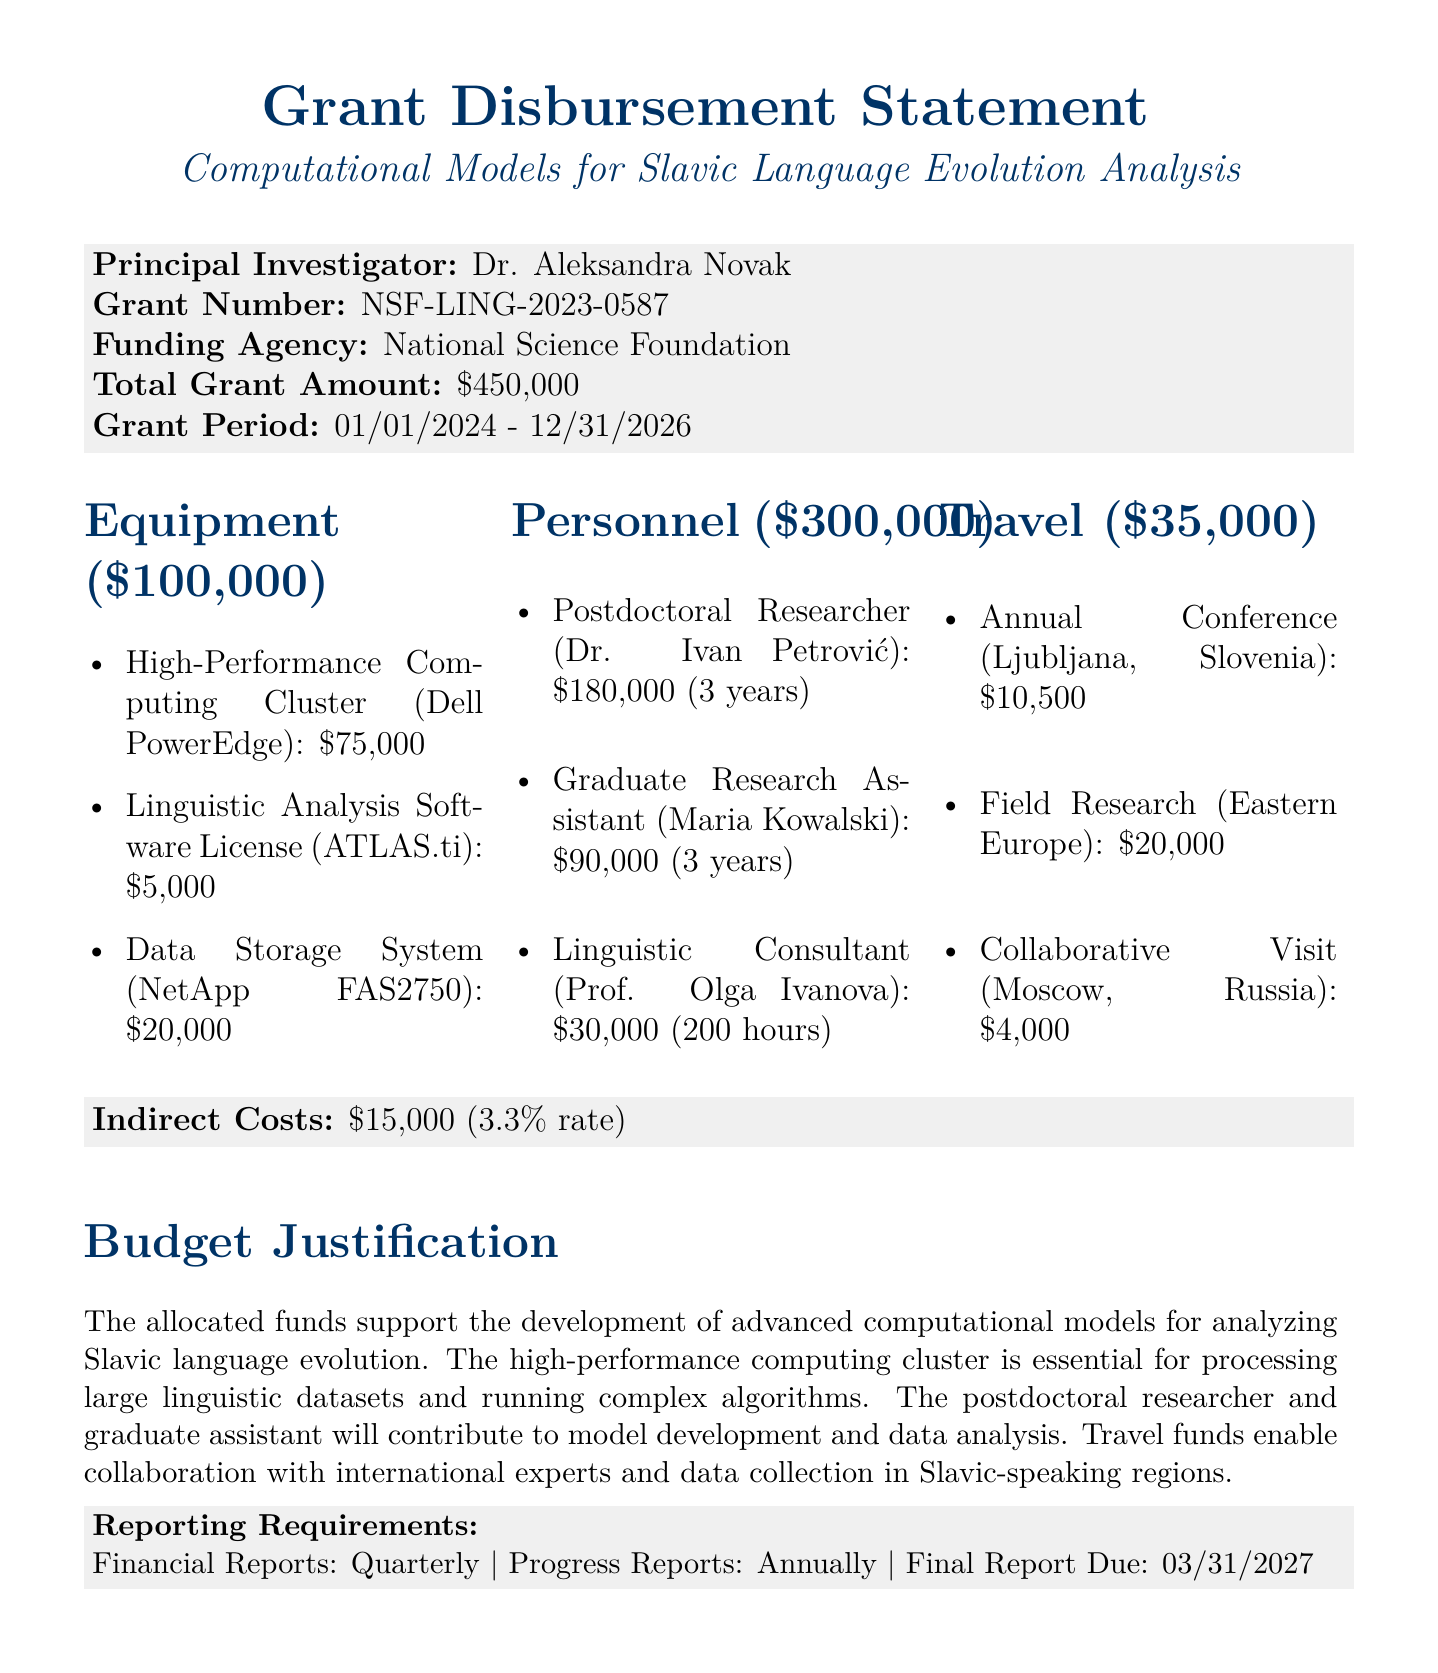What is the project title? The project title is stated at the beginning of the document, highlighting the focus on Slavic language evolution.
Answer: Computational Models for Slavic Language Evolution Analysis Who is the principal investigator? The principal investigator's name is provided in the section detailing the grant's key personnel.
Answer: Dr. Aleksandra Novak What is the total grant amount? The total grant amount is explicitly mentioned in the grant details.
Answer: $450,000 What is the total cost allocated for personnel? The document lists the total personnel cost as a specific figure.
Answer: $300,000 How much is allocated for the High-Performance Computing Cluster? The document specifies the cost for the High-Performance Computing Cluster under the equipment category.
Answer: $75,000 What is the frequency of travel for the conference attendance? The frequency for the conference attendance is mentioned specifically in the travel section of the document.
Answer: Annually What is the total travel cost? The total travel cost is summed up in the travel category of the disbursement details.
Answer: $35,000 What is the indirect cost amount? The indirect cost is indicated as a separate expense in the document.
Answer: $15,000 When is the final report due? The document outlines the due date for the final report within the reporting requirements section.
Answer: 03/31/2027 